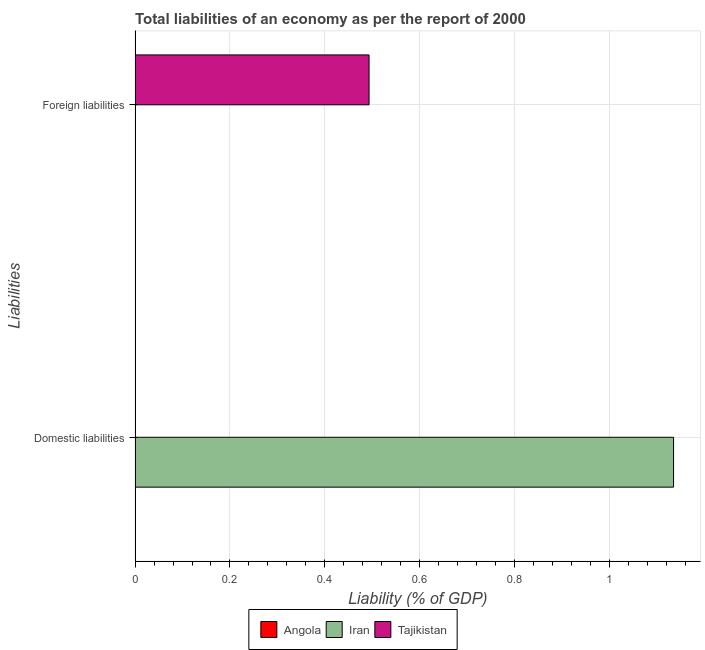Are the number of bars on each tick of the Y-axis equal?
Provide a succinct answer. No. What is the label of the 1st group of bars from the top?
Your answer should be very brief. Foreign liabilities. What is the incurrence of foreign liabilities in Tajikistan?
Keep it short and to the point. 0.49. Across all countries, what is the maximum incurrence of domestic liabilities?
Provide a short and direct response. 1.13. Across all countries, what is the minimum incurrence of foreign liabilities?
Your answer should be very brief. 0. In which country was the incurrence of domestic liabilities maximum?
Give a very brief answer. Iran. What is the total incurrence of foreign liabilities in the graph?
Offer a terse response. 0.49. What is the difference between the incurrence of foreign liabilities in Iran and that in Tajikistan?
Keep it short and to the point. -0.49. What is the difference between the incurrence of foreign liabilities in Angola and the incurrence of domestic liabilities in Tajikistan?
Your response must be concise. 0. What is the average incurrence of foreign liabilities per country?
Your answer should be very brief. 0.16. What is the difference between the incurrence of foreign liabilities and incurrence of domestic liabilities in Iran?
Your answer should be compact. -1.13. How many bars are there?
Ensure brevity in your answer.  3. How many countries are there in the graph?
Your answer should be compact. 3. Does the graph contain any zero values?
Offer a very short reply. Yes. What is the title of the graph?
Provide a short and direct response. Total liabilities of an economy as per the report of 2000. What is the label or title of the X-axis?
Offer a terse response. Liability (% of GDP). What is the label or title of the Y-axis?
Offer a terse response. Liabilities. What is the Liability (% of GDP) in Angola in Domestic liabilities?
Your response must be concise. 0. What is the Liability (% of GDP) in Iran in Domestic liabilities?
Provide a succinct answer. 1.13. What is the Liability (% of GDP) of Tajikistan in Domestic liabilities?
Provide a succinct answer. 0. What is the Liability (% of GDP) in Iran in Foreign liabilities?
Make the answer very short. 0. What is the Liability (% of GDP) of Tajikistan in Foreign liabilities?
Offer a very short reply. 0.49. Across all Liabilities, what is the maximum Liability (% of GDP) in Iran?
Your response must be concise. 1.13. Across all Liabilities, what is the maximum Liability (% of GDP) of Tajikistan?
Your response must be concise. 0.49. Across all Liabilities, what is the minimum Liability (% of GDP) of Iran?
Ensure brevity in your answer.  0. Across all Liabilities, what is the minimum Liability (% of GDP) of Tajikistan?
Your response must be concise. 0. What is the total Liability (% of GDP) in Angola in the graph?
Make the answer very short. 0. What is the total Liability (% of GDP) in Iran in the graph?
Your answer should be very brief. 1.13. What is the total Liability (% of GDP) in Tajikistan in the graph?
Keep it short and to the point. 0.49. What is the difference between the Liability (% of GDP) in Iran in Domestic liabilities and that in Foreign liabilities?
Your response must be concise. 1.13. What is the difference between the Liability (% of GDP) in Iran in Domestic liabilities and the Liability (% of GDP) in Tajikistan in Foreign liabilities?
Offer a terse response. 0.64. What is the average Liability (% of GDP) in Iran per Liabilities?
Provide a succinct answer. 0.57. What is the average Liability (% of GDP) in Tajikistan per Liabilities?
Provide a succinct answer. 0.25. What is the difference between the Liability (% of GDP) of Iran and Liability (% of GDP) of Tajikistan in Foreign liabilities?
Your answer should be very brief. -0.49. What is the ratio of the Liability (% of GDP) in Iran in Domestic liabilities to that in Foreign liabilities?
Keep it short and to the point. 1.11e+04. What is the difference between the highest and the second highest Liability (% of GDP) of Iran?
Provide a short and direct response. 1.13. What is the difference between the highest and the lowest Liability (% of GDP) of Iran?
Provide a succinct answer. 1.13. What is the difference between the highest and the lowest Liability (% of GDP) of Tajikistan?
Offer a very short reply. 0.49. 